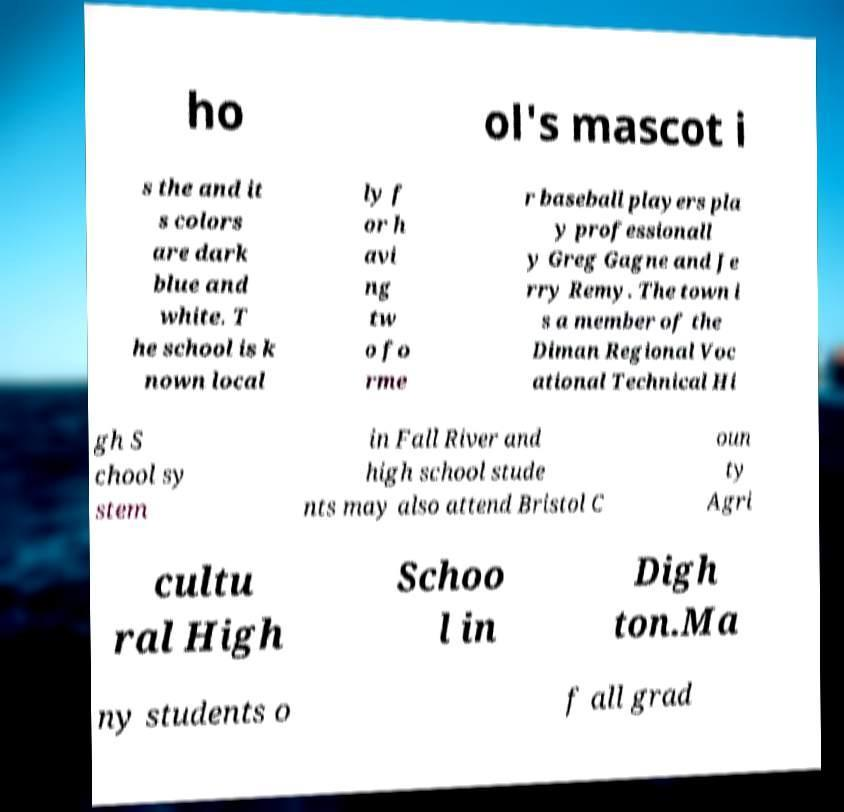Please identify and transcribe the text found in this image. ho ol's mascot i s the and it s colors are dark blue and white. T he school is k nown local ly f or h avi ng tw o fo rme r baseball players pla y professionall y Greg Gagne and Je rry Remy. The town i s a member of the Diman Regional Voc ational Technical Hi gh S chool sy stem in Fall River and high school stude nts may also attend Bristol C oun ty Agri cultu ral High Schoo l in Digh ton.Ma ny students o f all grad 